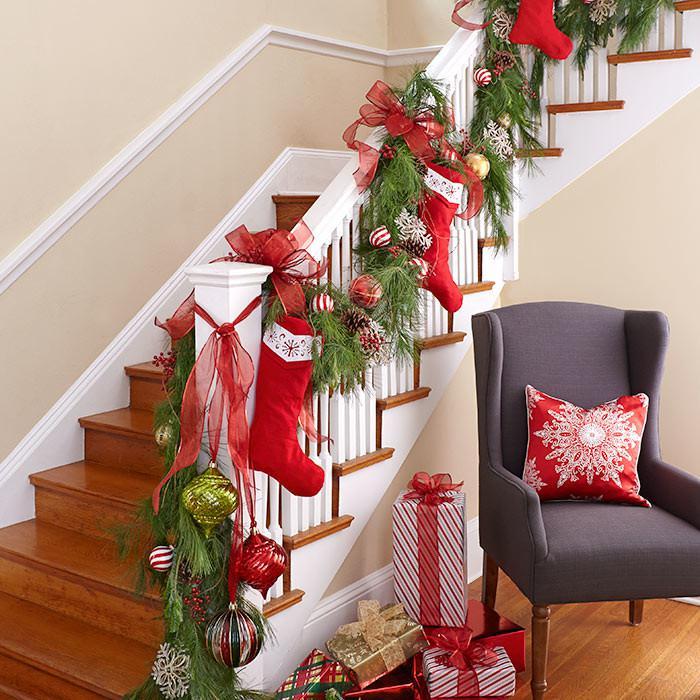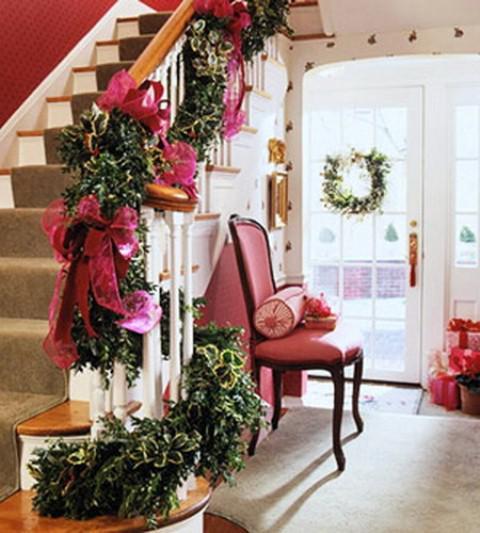The first image is the image on the left, the second image is the image on the right. Examine the images to the left and right. Is the description "There is a railing decorated with holiday lights." accurate? Answer yes or no. No. The first image is the image on the left, the second image is the image on the right. Examine the images to the left and right. Is the description "Stockings are hanging from the left staircase." accurate? Answer yes or no. Yes. 